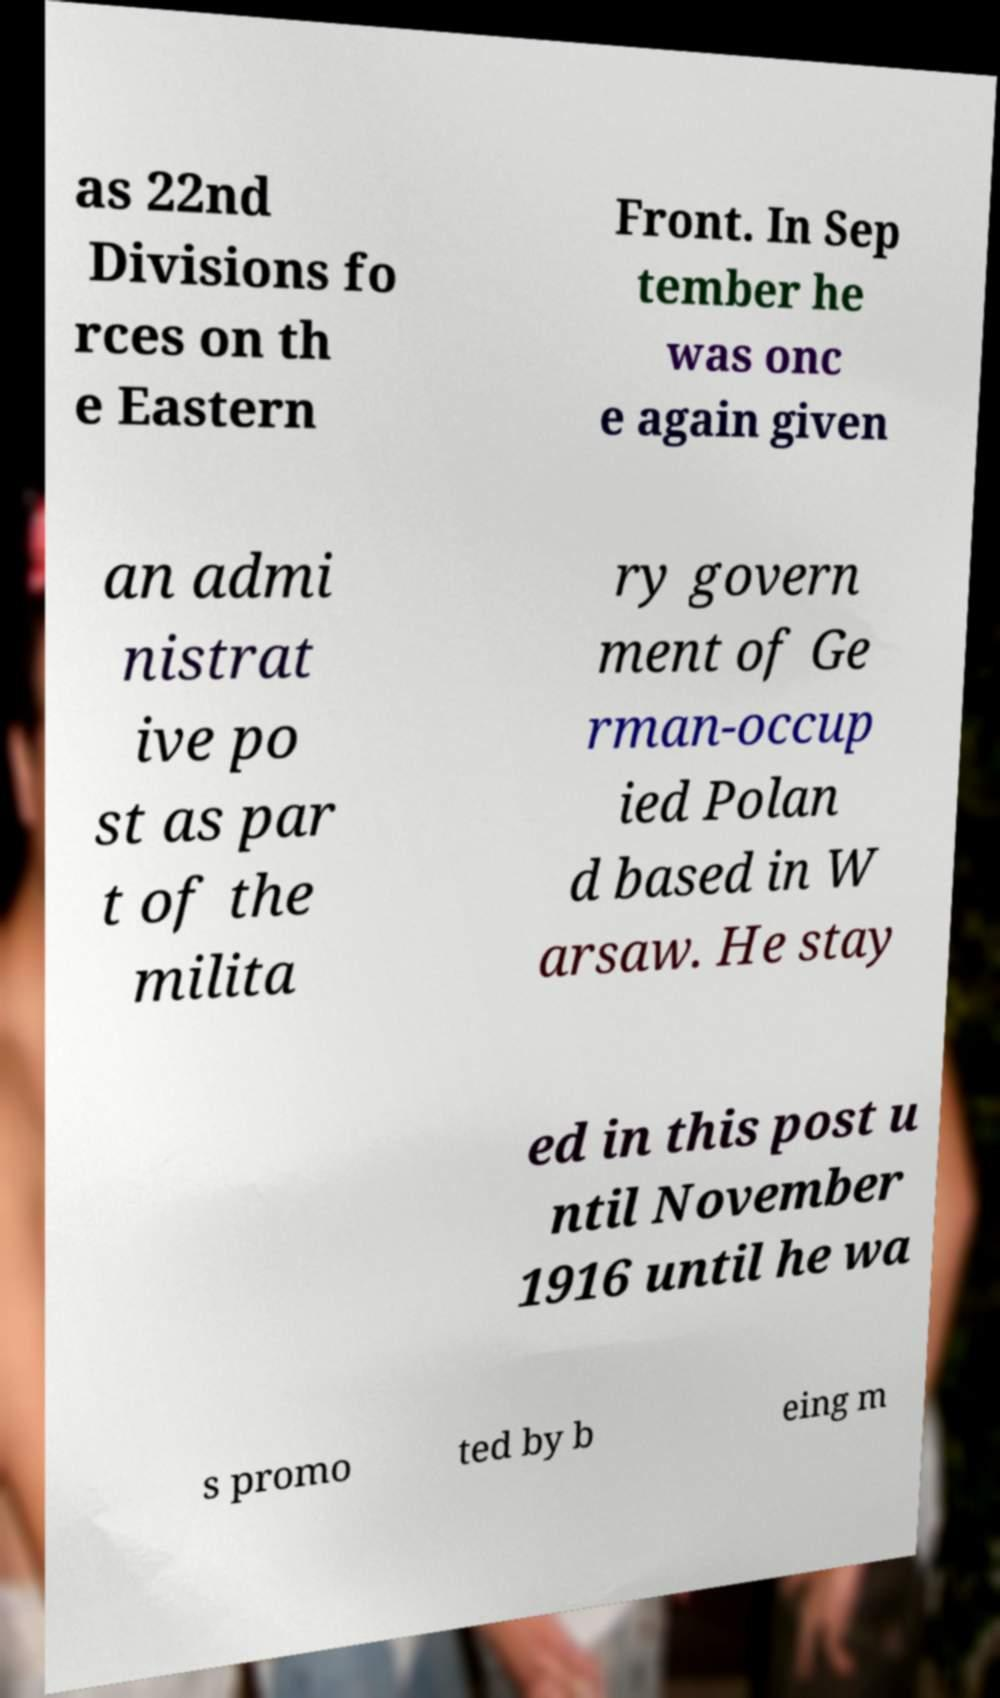Can you read and provide the text displayed in the image?This photo seems to have some interesting text. Can you extract and type it out for me? as 22nd Divisions fo rces on th e Eastern Front. In Sep tember he was onc e again given an admi nistrat ive po st as par t of the milita ry govern ment of Ge rman-occup ied Polan d based in W arsaw. He stay ed in this post u ntil November 1916 until he wa s promo ted by b eing m 